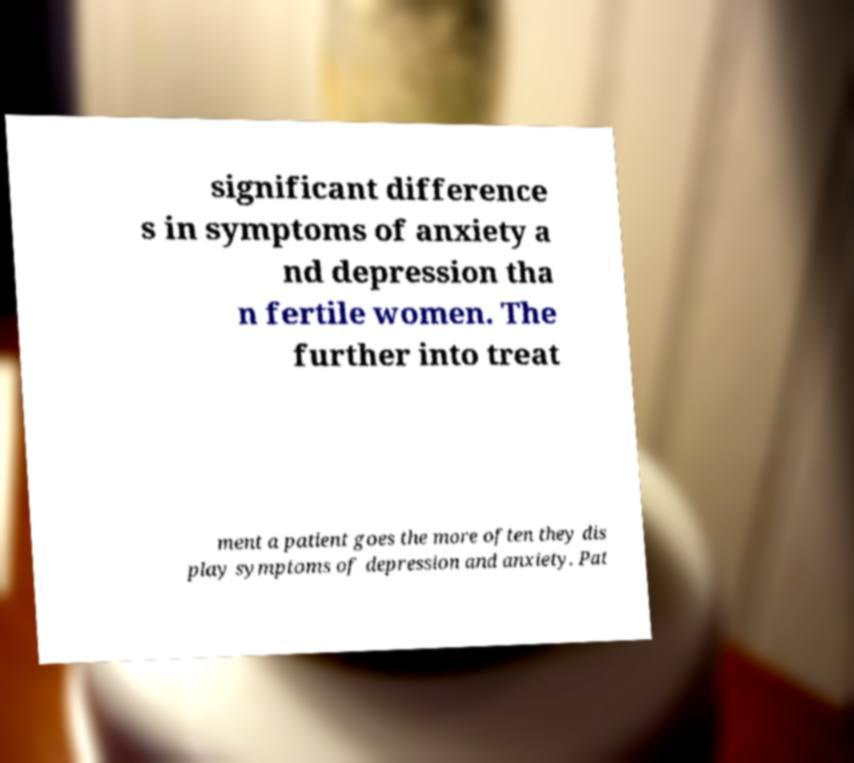What messages or text are displayed in this image? I need them in a readable, typed format. significant difference s in symptoms of anxiety a nd depression tha n fertile women. The further into treat ment a patient goes the more often they dis play symptoms of depression and anxiety. Pat 